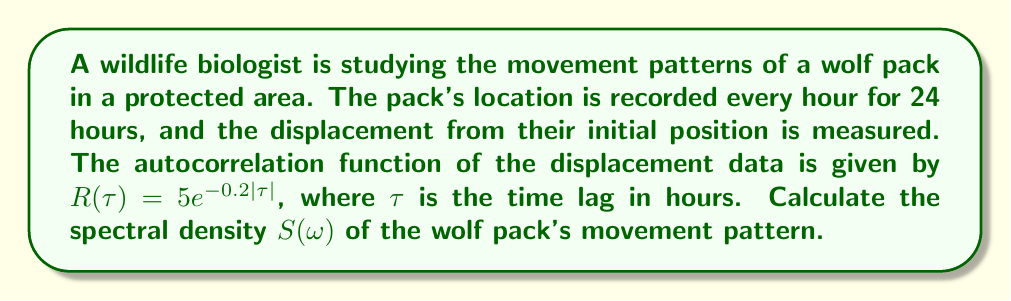Provide a solution to this math problem. To calculate the spectral density $S(\omega)$, we need to follow these steps:

1) The spectral density is the Fourier transform of the autocorrelation function. For a continuous-time process, the relationship is given by:

   $$S(\omega) = \int_{-\infty}^{\infty} R(\tau) e^{-i\omega\tau} d\tau$$

2) In our case, $R(\tau) = 5e^{-0.2|\tau|}$. We can split this integral into two parts due to the absolute value:

   $$S(\omega) = \int_{-\infty}^{0} 5e^{0.2\tau} e^{-i\omega\tau} d\tau + \int_{0}^{\infty} 5e^{-0.2\tau} e^{-i\omega\tau} d\tau$$

3) Let's solve each integral separately:

   For $\tau < 0$:
   $$I_1 = 5\int_{-\infty}^{0} e^{(0.2-i\omega)\tau} d\tau = 5 \left[\frac{e^{(0.2-i\omega)\tau}}{0.2-i\omega}\right]_{-\infty}^{0} = \frac{5}{0.2-i\omega}$$

   For $\tau > 0$:
   $$I_2 = 5\int_{0}^{\infty} e^{(-0.2-i\omega)\tau} d\tau = 5 \left[-\frac{e^{(-0.2-i\omega)\tau}}{0.2+i\omega}\right]_{0}^{\infty} = \frac{5}{0.2+i\omega}$$

4) The total spectral density is the sum of these two integrals:

   $$S(\omega) = I_1 + I_2 = \frac{5}{0.2-i\omega} + \frac{5}{0.2+i\omega}$$

5) Simplifying this expression:

   $$S(\omega) = \frac{5(0.2+i\omega) + 5(0.2-i\omega)}{(0.2-i\omega)(0.2+i\omega)} = \frac{10(0.2)}{0.2^2+\omega^2} = \frac{2}{0.04+\omega^2}$$

Therefore, the spectral density of the wolf pack's movement pattern is:

$$S(\omega) = \frac{2}{0.04+\omega^2}$$
Answer: $S(\omega) = \frac{2}{0.04+\omega^2}$ 